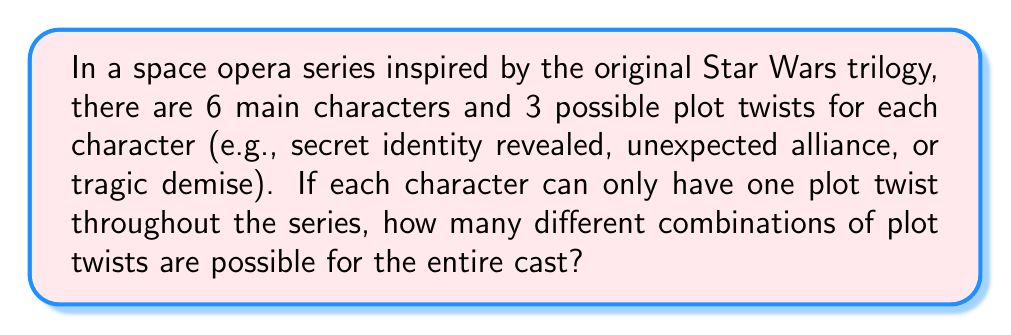Can you answer this question? Let's approach this step-by-step:

1) We have 6 main characters, and each character can have one of 3 possible plot twists or no plot twist at all.

2) For each character, we have 4 options (3 plot twists + 1 no twist option).

3) This is a perfect scenario for using the multiplication principle in combinatorics.

4) The total number of possibilities is the product of the number of options for each character:

   $$ 4 \times 4 \times 4 \times 4 \times 4 \times 4 = 4^6 $$

5) We can calculate this:

   $$ 4^6 = 4 \times 4 \times 4 \times 4 \times 4 \times 4 = 4,096 $$

6) Therefore, there are 4,096 different combinations of plot twists possible for the entire cast.

This large number of possibilities demonstrates the vast potential for unique storylines in a space opera series, much like the unexpected twists that made the original Star Wars trilogy so impactful in science fiction cinema.
Answer: $4^6 = 4,096$ 